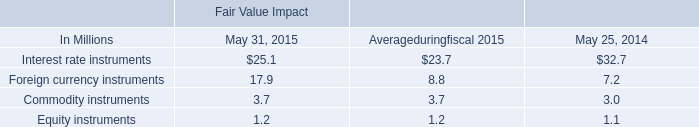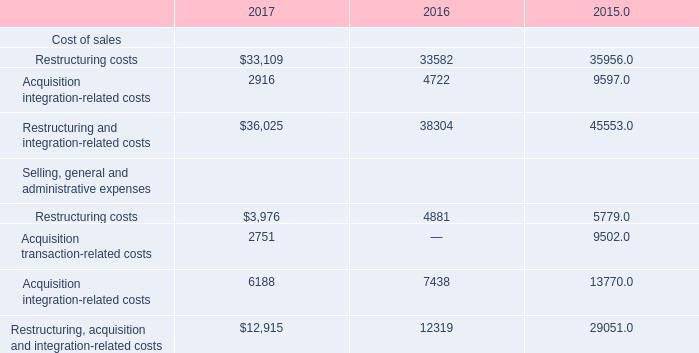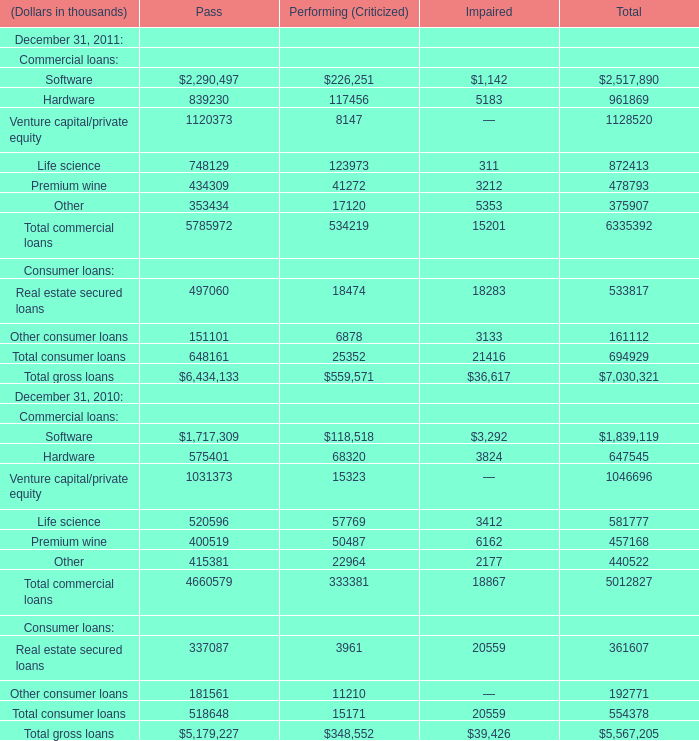Which year is Total consumer loans for Pass on December 31 higher? 
Answer: 2011. 